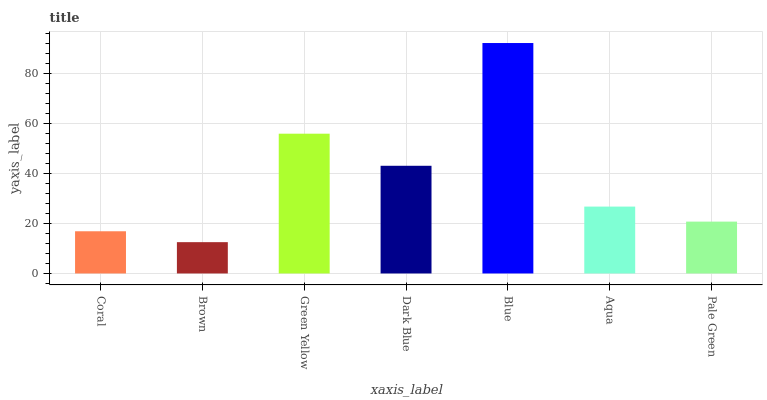Is Brown the minimum?
Answer yes or no. Yes. Is Blue the maximum?
Answer yes or no. Yes. Is Green Yellow the minimum?
Answer yes or no. No. Is Green Yellow the maximum?
Answer yes or no. No. Is Green Yellow greater than Brown?
Answer yes or no. Yes. Is Brown less than Green Yellow?
Answer yes or no. Yes. Is Brown greater than Green Yellow?
Answer yes or no. No. Is Green Yellow less than Brown?
Answer yes or no. No. Is Aqua the high median?
Answer yes or no. Yes. Is Aqua the low median?
Answer yes or no. Yes. Is Coral the high median?
Answer yes or no. No. Is Blue the low median?
Answer yes or no. No. 